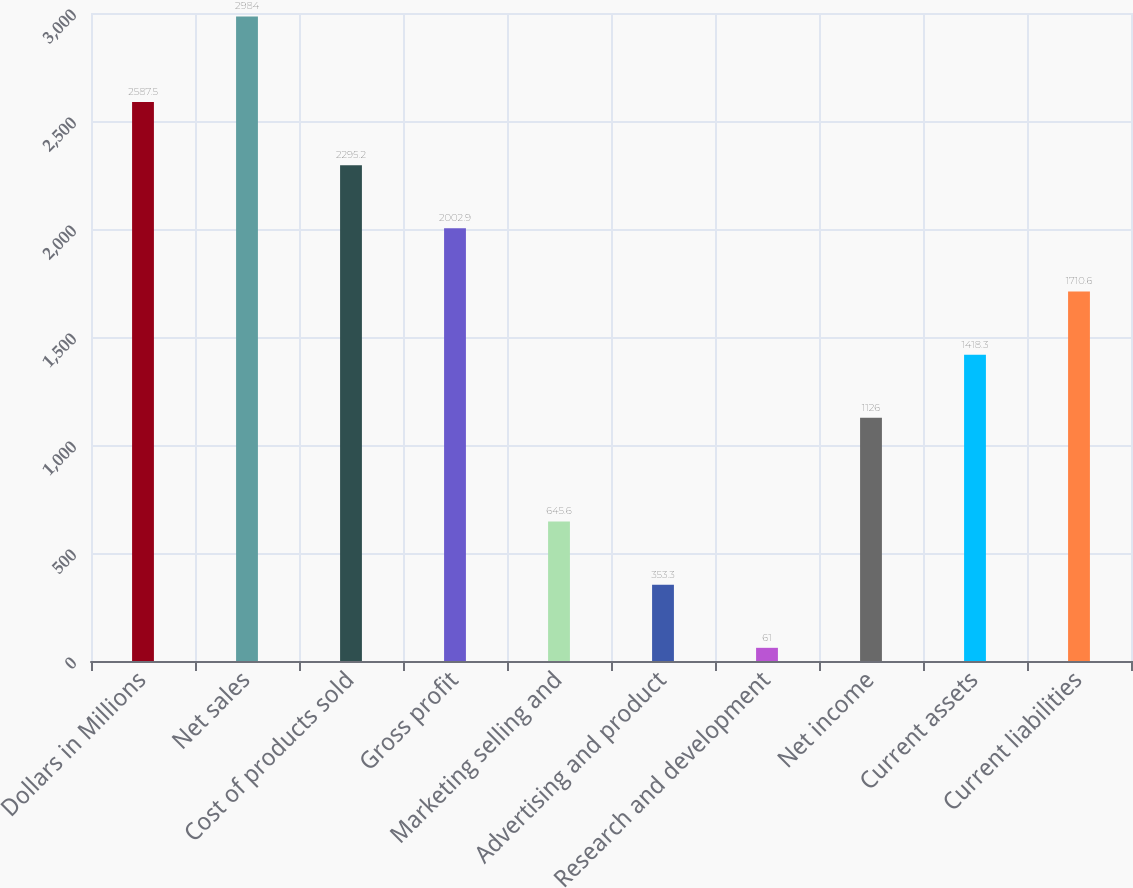Convert chart. <chart><loc_0><loc_0><loc_500><loc_500><bar_chart><fcel>Dollars in Millions<fcel>Net sales<fcel>Cost of products sold<fcel>Gross profit<fcel>Marketing selling and<fcel>Advertising and product<fcel>Research and development<fcel>Net income<fcel>Current assets<fcel>Current liabilities<nl><fcel>2587.5<fcel>2984<fcel>2295.2<fcel>2002.9<fcel>645.6<fcel>353.3<fcel>61<fcel>1126<fcel>1418.3<fcel>1710.6<nl></chart> 